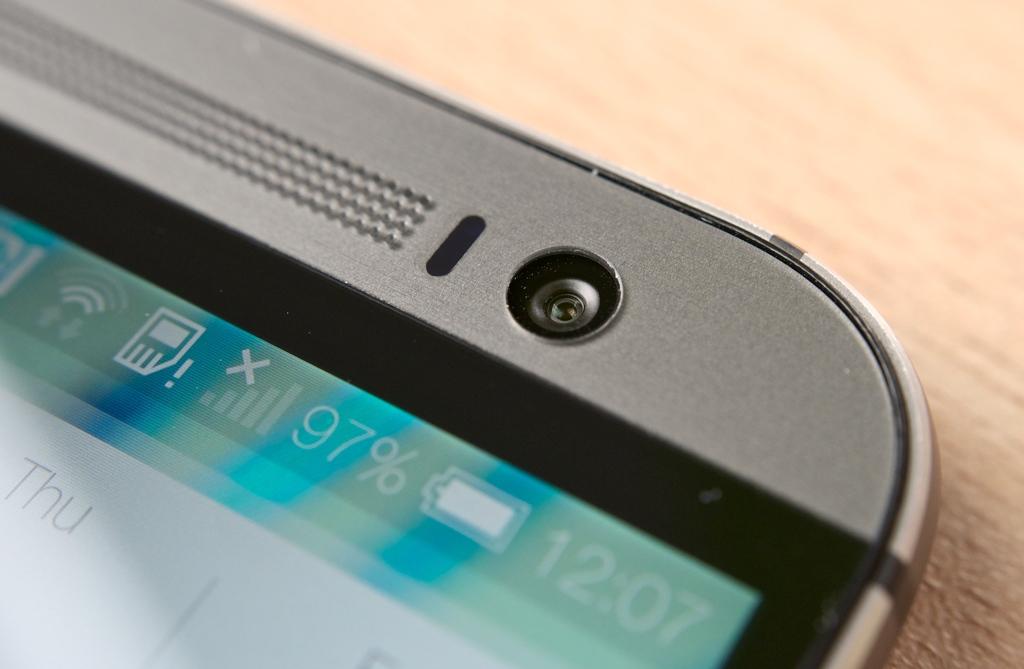How much more battery does the phone have?
Ensure brevity in your answer.  97%. 